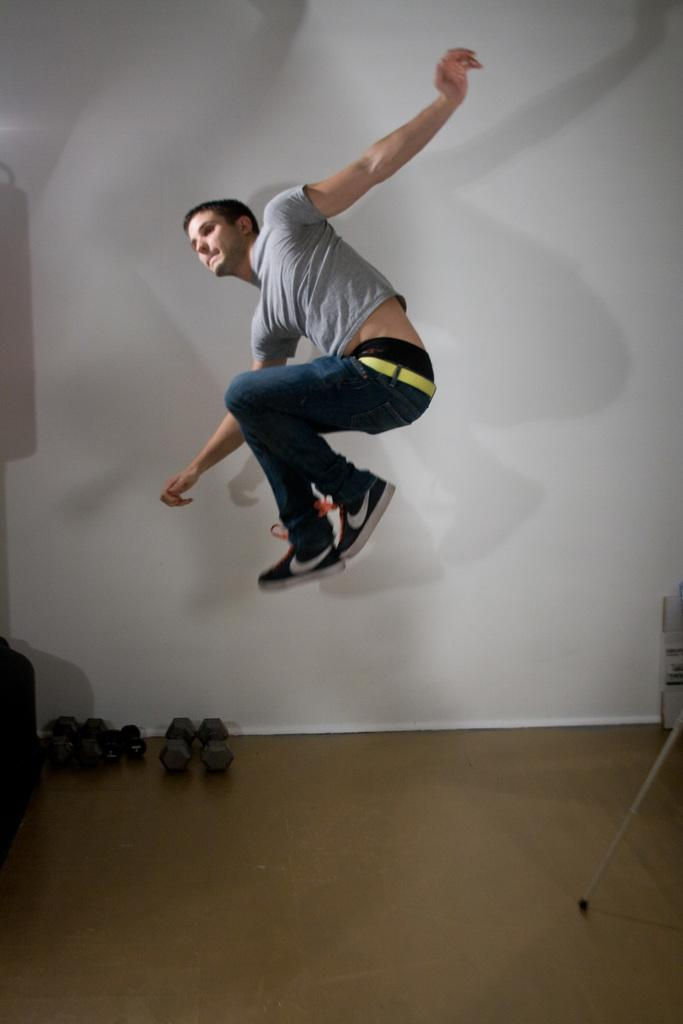What is the main subject of the image? There is a person in the image. What is the person wearing? The person is wearing an ash-colored T-shirt and blue jeans. What is the person doing in the image? The person is jumping in the air. What can be seen in the background of the image? There are dumbbells and a wall in the background of the image. What type of twig can be seen in the person's hand in the image? There is no twig present in the person's hand or in the image. What view can be seen from the top of the wall in the image? The image does not provide a view from the top of the wall, as it only shows the wall in the background. 